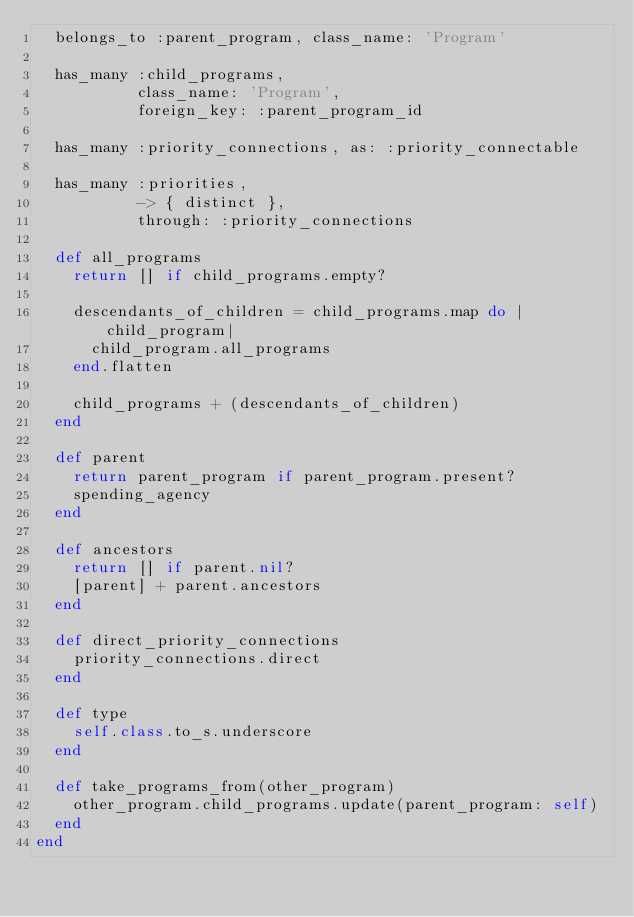Convert code to text. <code><loc_0><loc_0><loc_500><loc_500><_Ruby_>  belongs_to :parent_program, class_name: 'Program'

  has_many :child_programs,
           class_name: 'Program',
           foreign_key: :parent_program_id

  has_many :priority_connections, as: :priority_connectable

  has_many :priorities,
           -> { distinct },
           through: :priority_connections

  def all_programs
    return [] if child_programs.empty?

    descendants_of_children = child_programs.map do |child_program|
      child_program.all_programs
    end.flatten

    child_programs + (descendants_of_children)
  end

  def parent
    return parent_program if parent_program.present?
    spending_agency
  end

  def ancestors
    return [] if parent.nil?
    [parent] + parent.ancestors
  end

  def direct_priority_connections
    priority_connections.direct
  end

  def type
    self.class.to_s.underscore
  end

  def take_programs_from(other_program)
    other_program.child_programs.update(parent_program: self)
  end
end
</code> 